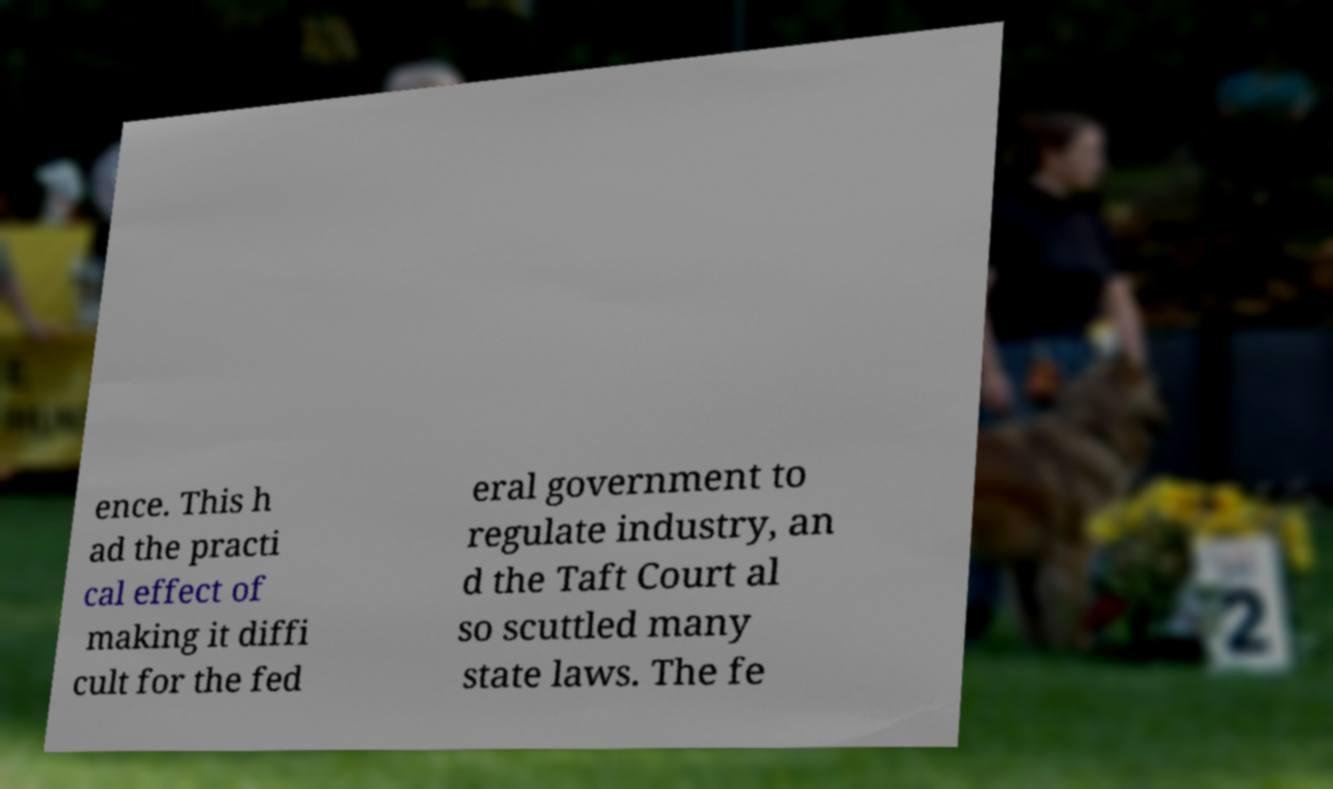There's text embedded in this image that I need extracted. Can you transcribe it verbatim? ence. This h ad the practi cal effect of making it diffi cult for the fed eral government to regulate industry, an d the Taft Court al so scuttled many state laws. The fe 